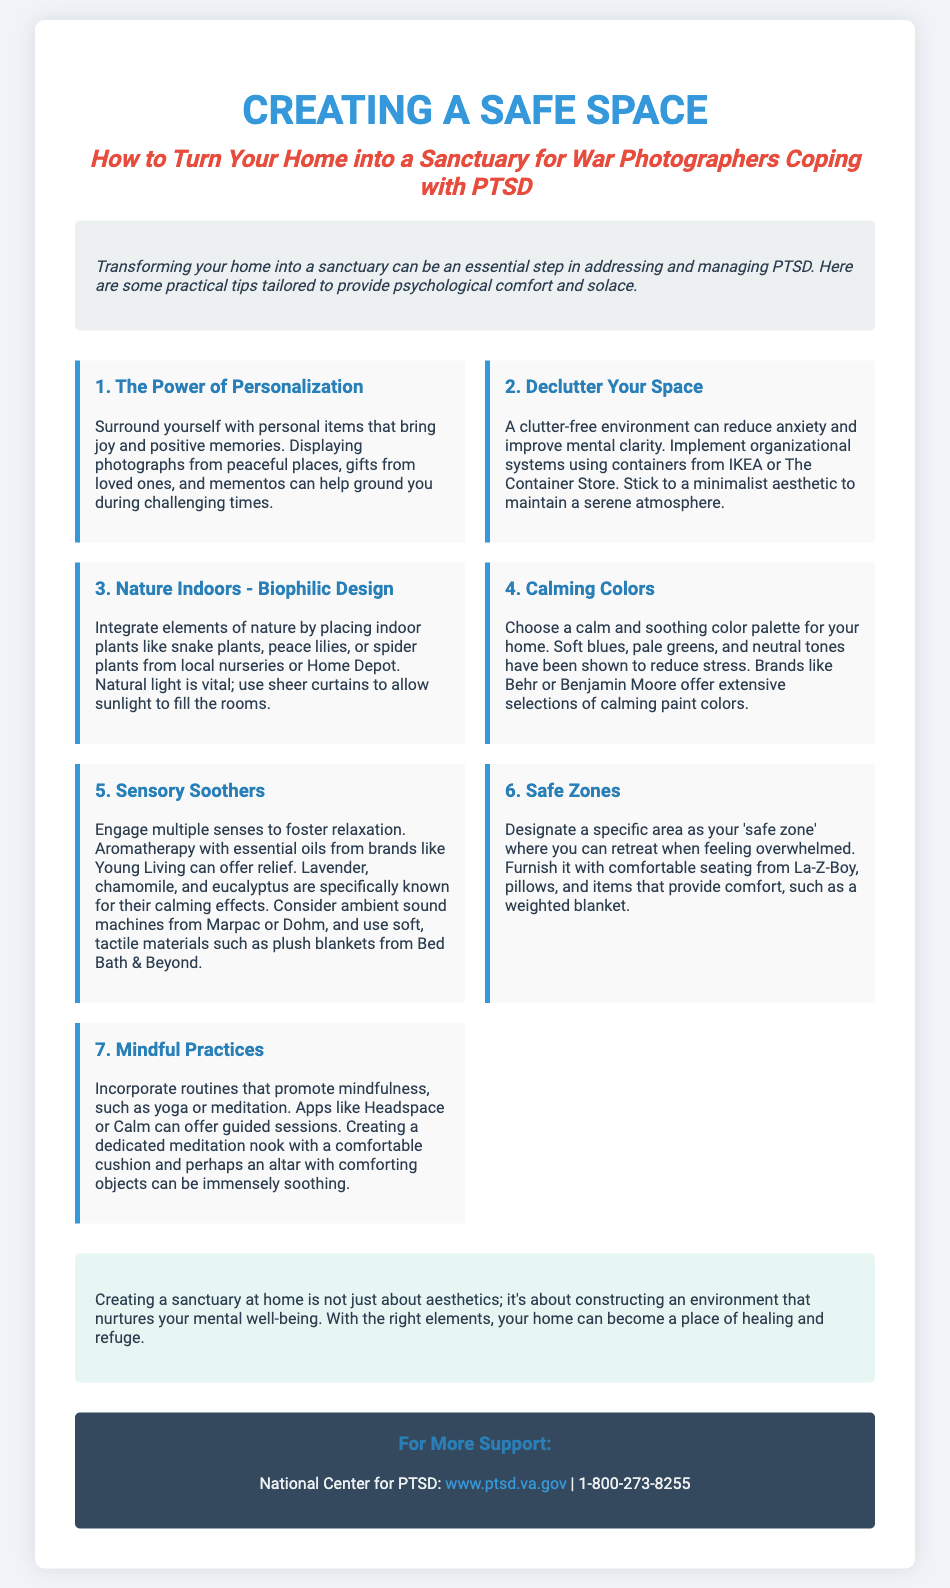What is the title of the poster? The title is the main heading of the document, which indicates the theme of the content.
Answer: Creating a Safe Space What color palette is suggested for calming the home? The document provides specific color suggestions that promote a calming atmosphere.
Answer: Soft blues, pale greens, and neutral tones What is the first tip listed for creating a safe space? This refers to the sequence of suggestions provided in the document for transforming a home.
Answer: The Power of Personalization Which type of plants are recommended for biophilic design? The document mentions specific plants that can enhance indoor nature elements.
Answer: Snake plants, peace lilies, or spider plants What essential oil is known for its calming effects? This asks for a specific example provided in the document regarding sensory soothers.
Answer: Lavender How can you designate a "safe zone" in your home? This question covers advice on creating a specific area for feeling secure and relaxed.
Answer: Designate a specific area What are recommended apps for mindfulness practices? This seeks to find specific tools mentioned in the document for enhancing mindfulness.
Answer: Headspace or Calm What is the website provided for more support? This question asks for specific contact information related to PTSD support in the document.
Answer: www.ptsd.va.gov How should the introduction be characterized? This question looks for the tone or style of the introductory section of the poster.
Answer: Italic 